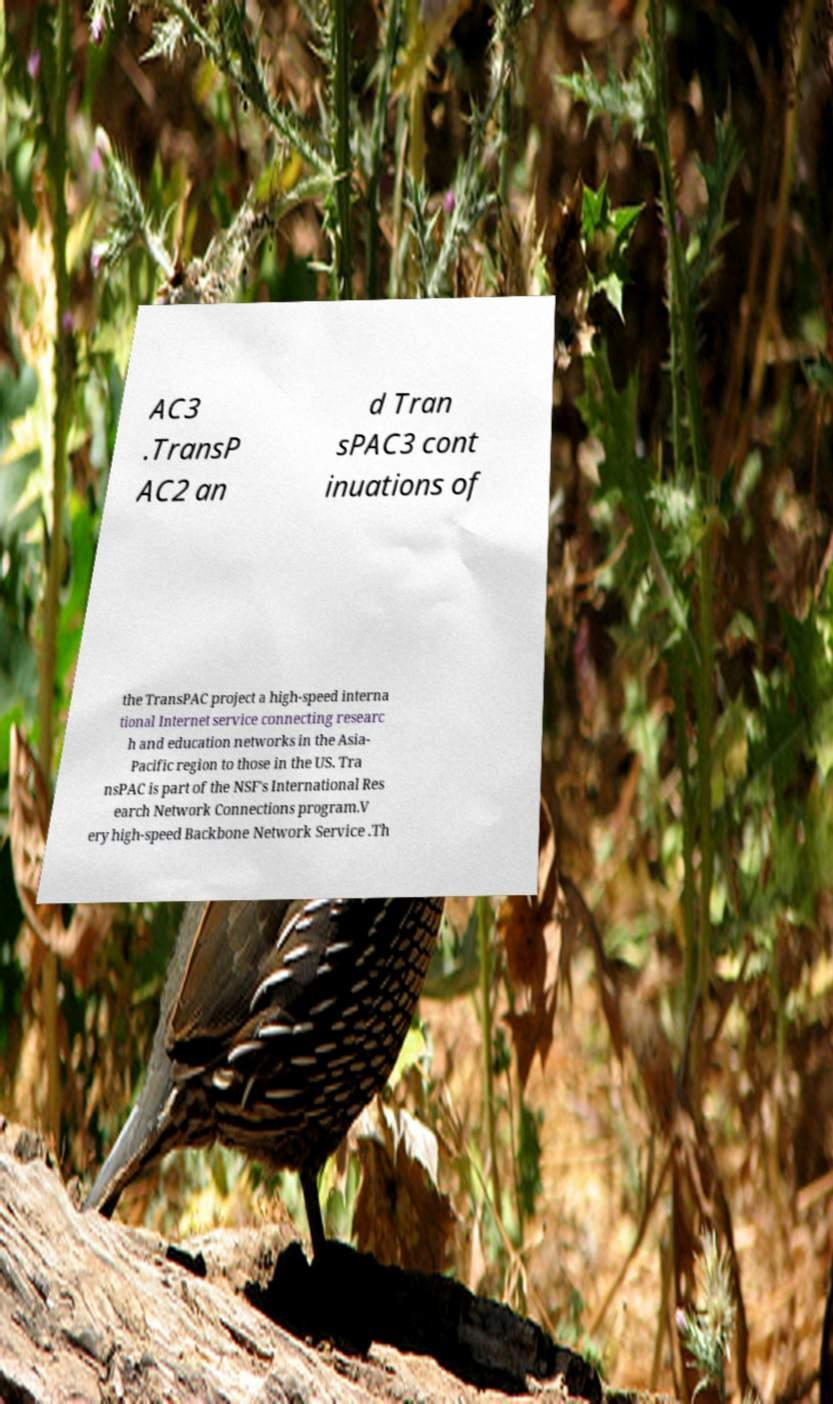What messages or text are displayed in this image? I need them in a readable, typed format. AC3 .TransP AC2 an d Tran sPAC3 cont inuations of the TransPAC project a high-speed interna tional Internet service connecting researc h and education networks in the Asia- Pacific region to those in the US. Tra nsPAC is part of the NSF's International Res earch Network Connections program.V ery high-speed Backbone Network Service .Th 